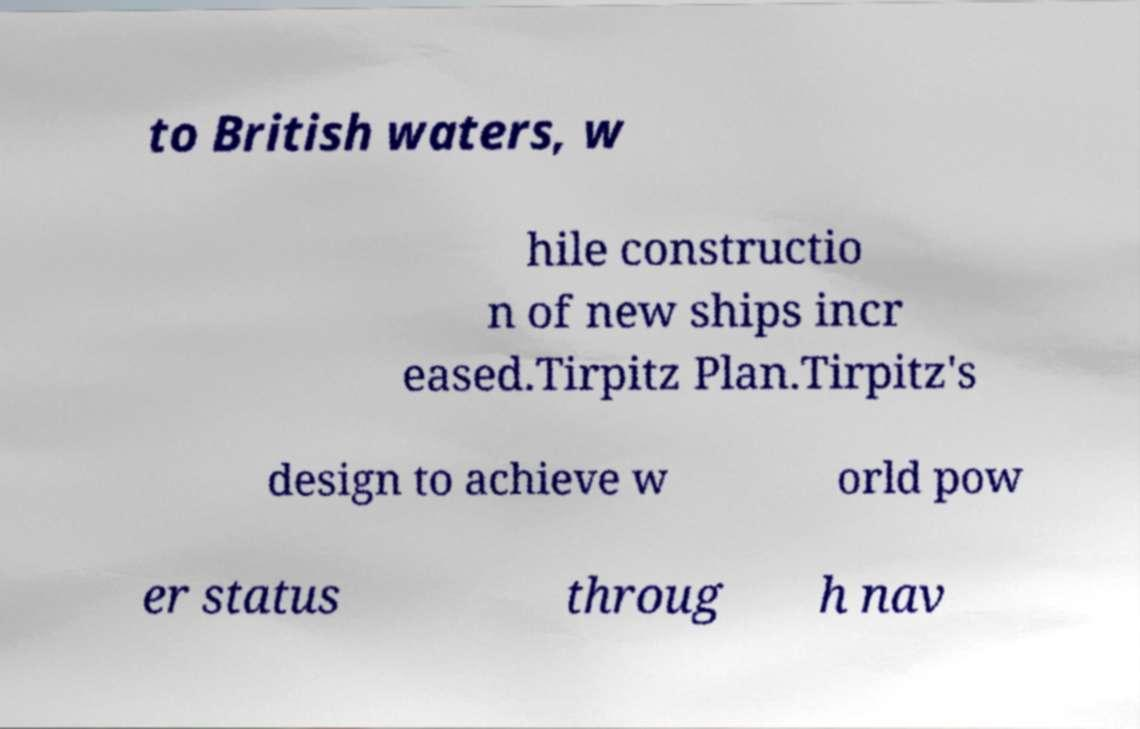For documentation purposes, I need the text within this image transcribed. Could you provide that? to British waters, w hile constructio n of new ships incr eased.Tirpitz Plan.Tirpitz's design to achieve w orld pow er status throug h nav 